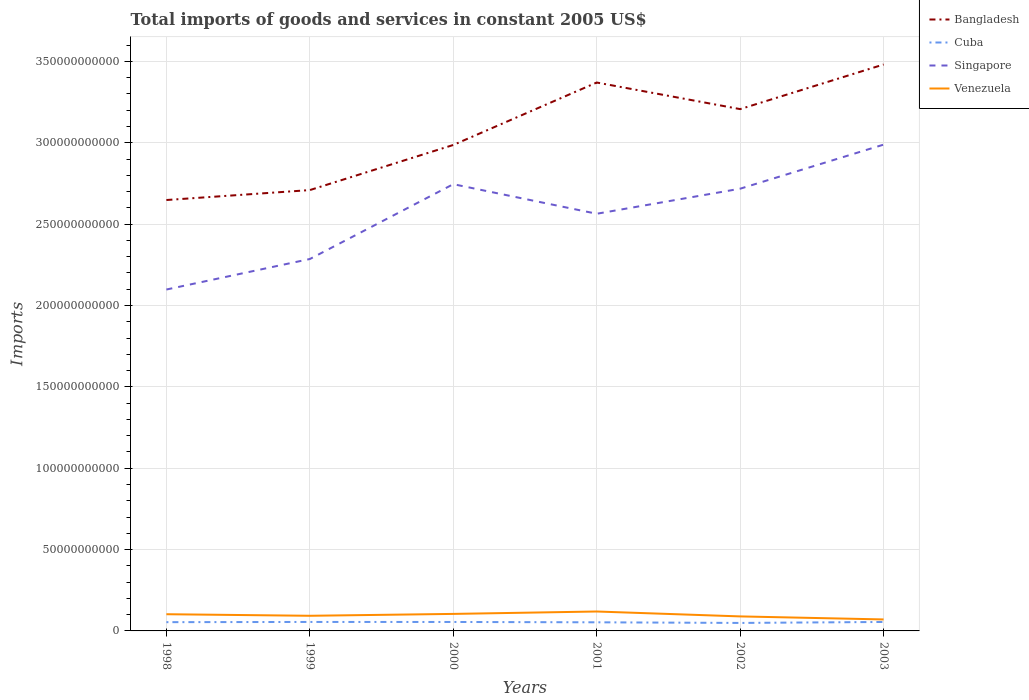How many different coloured lines are there?
Provide a succinct answer. 4. Is the number of lines equal to the number of legend labels?
Provide a succinct answer. Yes. Across all years, what is the maximum total imports of goods and services in Singapore?
Offer a terse response. 2.10e+11. What is the total total imports of goods and services in Bangladesh in the graph?
Your response must be concise. -4.98e+1. What is the difference between the highest and the second highest total imports of goods and services in Venezuela?
Provide a short and direct response. 4.87e+09. What is the difference between the highest and the lowest total imports of goods and services in Venezuela?
Make the answer very short. 3. How many years are there in the graph?
Keep it short and to the point. 6. What is the difference between two consecutive major ticks on the Y-axis?
Offer a terse response. 5.00e+1. Are the values on the major ticks of Y-axis written in scientific E-notation?
Offer a very short reply. No. Does the graph contain any zero values?
Your answer should be very brief. No. Where does the legend appear in the graph?
Provide a short and direct response. Top right. How many legend labels are there?
Your answer should be very brief. 4. How are the legend labels stacked?
Your answer should be compact. Vertical. What is the title of the graph?
Your answer should be compact. Total imports of goods and services in constant 2005 US$. What is the label or title of the Y-axis?
Your response must be concise. Imports. What is the Imports of Bangladesh in 1998?
Give a very brief answer. 2.65e+11. What is the Imports of Cuba in 1998?
Offer a terse response. 5.38e+09. What is the Imports in Singapore in 1998?
Your response must be concise. 2.10e+11. What is the Imports in Venezuela in 1998?
Offer a terse response. 1.03e+1. What is the Imports of Bangladesh in 1999?
Give a very brief answer. 2.71e+11. What is the Imports in Cuba in 1999?
Your answer should be very brief. 5.52e+09. What is the Imports of Singapore in 1999?
Your response must be concise. 2.29e+11. What is the Imports of Venezuela in 1999?
Offer a terse response. 9.30e+09. What is the Imports in Bangladesh in 2000?
Make the answer very short. 2.99e+11. What is the Imports in Cuba in 2000?
Offer a terse response. 5.50e+09. What is the Imports in Singapore in 2000?
Make the answer very short. 2.75e+11. What is the Imports of Venezuela in 2000?
Provide a succinct answer. 1.05e+1. What is the Imports in Bangladesh in 2001?
Offer a very short reply. 3.37e+11. What is the Imports of Cuba in 2001?
Keep it short and to the point. 5.30e+09. What is the Imports in Singapore in 2001?
Provide a short and direct response. 2.56e+11. What is the Imports of Venezuela in 2001?
Your answer should be very brief. 1.19e+1. What is the Imports in Bangladesh in 2002?
Your response must be concise. 3.21e+11. What is the Imports of Cuba in 2002?
Offer a terse response. 4.91e+09. What is the Imports in Singapore in 2002?
Give a very brief answer. 2.72e+11. What is the Imports in Venezuela in 2002?
Provide a short and direct response. 8.92e+09. What is the Imports of Bangladesh in 2003?
Your answer should be very brief. 3.48e+11. What is the Imports of Cuba in 2003?
Your response must be concise. 5.51e+09. What is the Imports in Singapore in 2003?
Keep it short and to the point. 2.99e+11. What is the Imports in Venezuela in 2003?
Your answer should be very brief. 7.06e+09. Across all years, what is the maximum Imports of Bangladesh?
Provide a succinct answer. 3.48e+11. Across all years, what is the maximum Imports in Cuba?
Your answer should be compact. 5.52e+09. Across all years, what is the maximum Imports in Singapore?
Provide a succinct answer. 2.99e+11. Across all years, what is the maximum Imports of Venezuela?
Offer a very short reply. 1.19e+1. Across all years, what is the minimum Imports of Bangladesh?
Your answer should be compact. 2.65e+11. Across all years, what is the minimum Imports of Cuba?
Your answer should be compact. 4.91e+09. Across all years, what is the minimum Imports of Singapore?
Provide a succinct answer. 2.10e+11. Across all years, what is the minimum Imports in Venezuela?
Give a very brief answer. 7.06e+09. What is the total Imports of Bangladesh in the graph?
Give a very brief answer. 1.84e+12. What is the total Imports of Cuba in the graph?
Provide a succinct answer. 3.21e+1. What is the total Imports of Singapore in the graph?
Your response must be concise. 1.54e+12. What is the total Imports of Venezuela in the graph?
Offer a terse response. 5.79e+1. What is the difference between the Imports of Bangladesh in 1998 and that in 1999?
Ensure brevity in your answer.  -6.11e+09. What is the difference between the Imports of Cuba in 1998 and that in 1999?
Offer a terse response. -1.31e+08. What is the difference between the Imports of Singapore in 1998 and that in 1999?
Your response must be concise. -1.87e+1. What is the difference between the Imports of Venezuela in 1998 and that in 1999?
Provide a short and direct response. 9.57e+08. What is the difference between the Imports of Bangladesh in 1998 and that in 2000?
Ensure brevity in your answer.  -3.38e+1. What is the difference between the Imports in Cuba in 1998 and that in 2000?
Keep it short and to the point. -1.19e+08. What is the difference between the Imports in Singapore in 1998 and that in 2000?
Your answer should be compact. -6.47e+1. What is the difference between the Imports in Venezuela in 1998 and that in 2000?
Offer a terse response. -1.96e+08. What is the difference between the Imports in Bangladesh in 1998 and that in 2001?
Ensure brevity in your answer.  -7.22e+1. What is the difference between the Imports of Cuba in 1998 and that in 2001?
Offer a very short reply. 8.78e+07. What is the difference between the Imports in Singapore in 1998 and that in 2001?
Ensure brevity in your answer.  -4.66e+1. What is the difference between the Imports of Venezuela in 1998 and that in 2001?
Your answer should be compact. -1.67e+09. What is the difference between the Imports in Bangladesh in 1998 and that in 2002?
Keep it short and to the point. -5.59e+1. What is the difference between the Imports of Cuba in 1998 and that in 2002?
Ensure brevity in your answer.  4.75e+08. What is the difference between the Imports in Singapore in 1998 and that in 2002?
Offer a very short reply. -6.20e+1. What is the difference between the Imports in Venezuela in 1998 and that in 2002?
Offer a very short reply. 1.34e+09. What is the difference between the Imports in Bangladesh in 1998 and that in 2003?
Offer a very short reply. -8.33e+1. What is the difference between the Imports of Cuba in 1998 and that in 2003?
Make the answer very short. -1.21e+08. What is the difference between the Imports of Singapore in 1998 and that in 2003?
Make the answer very short. -8.91e+1. What is the difference between the Imports in Venezuela in 1998 and that in 2003?
Provide a succinct answer. 3.20e+09. What is the difference between the Imports in Bangladesh in 1999 and that in 2000?
Provide a short and direct response. -2.77e+1. What is the difference between the Imports of Cuba in 1999 and that in 2000?
Offer a terse response. 1.22e+07. What is the difference between the Imports in Singapore in 1999 and that in 2000?
Provide a succinct answer. -4.60e+1. What is the difference between the Imports in Venezuela in 1999 and that in 2000?
Ensure brevity in your answer.  -1.15e+09. What is the difference between the Imports in Bangladesh in 1999 and that in 2001?
Make the answer very short. -6.61e+1. What is the difference between the Imports in Cuba in 1999 and that in 2001?
Give a very brief answer. 2.19e+08. What is the difference between the Imports in Singapore in 1999 and that in 2001?
Ensure brevity in your answer.  -2.78e+1. What is the difference between the Imports of Venezuela in 1999 and that in 2001?
Make the answer very short. -2.63e+09. What is the difference between the Imports of Bangladesh in 1999 and that in 2002?
Offer a terse response. -4.98e+1. What is the difference between the Imports in Cuba in 1999 and that in 2002?
Ensure brevity in your answer.  6.05e+08. What is the difference between the Imports of Singapore in 1999 and that in 2002?
Keep it short and to the point. -4.32e+1. What is the difference between the Imports of Venezuela in 1999 and that in 2002?
Make the answer very short. 3.80e+08. What is the difference between the Imports of Bangladesh in 1999 and that in 2003?
Provide a short and direct response. -7.72e+1. What is the difference between the Imports in Cuba in 1999 and that in 2003?
Make the answer very short. 1.01e+07. What is the difference between the Imports in Singapore in 1999 and that in 2003?
Offer a terse response. -7.03e+1. What is the difference between the Imports of Venezuela in 1999 and that in 2003?
Give a very brief answer. 2.24e+09. What is the difference between the Imports of Bangladesh in 2000 and that in 2001?
Provide a succinct answer. -3.84e+1. What is the difference between the Imports in Cuba in 2000 and that in 2001?
Your response must be concise. 2.07e+08. What is the difference between the Imports in Singapore in 2000 and that in 2001?
Offer a terse response. 1.82e+1. What is the difference between the Imports in Venezuela in 2000 and that in 2001?
Provide a short and direct response. -1.48e+09. What is the difference between the Imports of Bangladesh in 2000 and that in 2002?
Make the answer very short. -2.20e+1. What is the difference between the Imports in Cuba in 2000 and that in 2002?
Your answer should be compact. 5.93e+08. What is the difference between the Imports in Singapore in 2000 and that in 2002?
Ensure brevity in your answer.  2.78e+09. What is the difference between the Imports in Venezuela in 2000 and that in 2002?
Keep it short and to the point. 1.53e+09. What is the difference between the Imports in Bangladesh in 2000 and that in 2003?
Keep it short and to the point. -4.95e+1. What is the difference between the Imports in Cuba in 2000 and that in 2003?
Your answer should be very brief. -2.11e+06. What is the difference between the Imports in Singapore in 2000 and that in 2003?
Give a very brief answer. -2.43e+1. What is the difference between the Imports of Venezuela in 2000 and that in 2003?
Provide a succinct answer. 3.40e+09. What is the difference between the Imports in Bangladesh in 2001 and that in 2002?
Your response must be concise. 1.63e+1. What is the difference between the Imports of Cuba in 2001 and that in 2002?
Give a very brief answer. 3.87e+08. What is the difference between the Imports of Singapore in 2001 and that in 2002?
Offer a very short reply. -1.54e+1. What is the difference between the Imports in Venezuela in 2001 and that in 2002?
Offer a terse response. 3.01e+09. What is the difference between the Imports in Bangladesh in 2001 and that in 2003?
Offer a terse response. -1.11e+1. What is the difference between the Imports in Cuba in 2001 and that in 2003?
Offer a terse response. -2.09e+08. What is the difference between the Imports in Singapore in 2001 and that in 2003?
Provide a short and direct response. -4.25e+1. What is the difference between the Imports of Venezuela in 2001 and that in 2003?
Make the answer very short. 4.87e+09. What is the difference between the Imports in Bangladesh in 2002 and that in 2003?
Give a very brief answer. -2.74e+1. What is the difference between the Imports of Cuba in 2002 and that in 2003?
Keep it short and to the point. -5.95e+08. What is the difference between the Imports of Singapore in 2002 and that in 2003?
Ensure brevity in your answer.  -2.71e+1. What is the difference between the Imports in Venezuela in 2002 and that in 2003?
Your response must be concise. 1.86e+09. What is the difference between the Imports in Bangladesh in 1998 and the Imports in Cuba in 1999?
Give a very brief answer. 2.59e+11. What is the difference between the Imports of Bangladesh in 1998 and the Imports of Singapore in 1999?
Your response must be concise. 3.63e+1. What is the difference between the Imports in Bangladesh in 1998 and the Imports in Venezuela in 1999?
Provide a short and direct response. 2.56e+11. What is the difference between the Imports of Cuba in 1998 and the Imports of Singapore in 1999?
Provide a short and direct response. -2.23e+11. What is the difference between the Imports of Cuba in 1998 and the Imports of Venezuela in 1999?
Offer a very short reply. -3.92e+09. What is the difference between the Imports of Singapore in 1998 and the Imports of Venezuela in 1999?
Make the answer very short. 2.01e+11. What is the difference between the Imports of Bangladesh in 1998 and the Imports of Cuba in 2000?
Give a very brief answer. 2.59e+11. What is the difference between the Imports in Bangladesh in 1998 and the Imports in Singapore in 2000?
Provide a succinct answer. -9.73e+09. What is the difference between the Imports in Bangladesh in 1998 and the Imports in Venezuela in 2000?
Offer a terse response. 2.54e+11. What is the difference between the Imports of Cuba in 1998 and the Imports of Singapore in 2000?
Give a very brief answer. -2.69e+11. What is the difference between the Imports of Cuba in 1998 and the Imports of Venezuela in 2000?
Offer a terse response. -5.07e+09. What is the difference between the Imports of Singapore in 1998 and the Imports of Venezuela in 2000?
Provide a succinct answer. 1.99e+11. What is the difference between the Imports in Bangladesh in 1998 and the Imports in Cuba in 2001?
Your answer should be very brief. 2.60e+11. What is the difference between the Imports in Bangladesh in 1998 and the Imports in Singapore in 2001?
Offer a terse response. 8.44e+09. What is the difference between the Imports in Bangladesh in 1998 and the Imports in Venezuela in 2001?
Provide a short and direct response. 2.53e+11. What is the difference between the Imports in Cuba in 1998 and the Imports in Singapore in 2001?
Your answer should be compact. -2.51e+11. What is the difference between the Imports of Cuba in 1998 and the Imports of Venezuela in 2001?
Offer a terse response. -6.55e+09. What is the difference between the Imports of Singapore in 1998 and the Imports of Venezuela in 2001?
Provide a succinct answer. 1.98e+11. What is the difference between the Imports of Bangladesh in 1998 and the Imports of Cuba in 2002?
Keep it short and to the point. 2.60e+11. What is the difference between the Imports of Bangladesh in 1998 and the Imports of Singapore in 2002?
Give a very brief answer. -6.95e+09. What is the difference between the Imports in Bangladesh in 1998 and the Imports in Venezuela in 2002?
Give a very brief answer. 2.56e+11. What is the difference between the Imports in Cuba in 1998 and the Imports in Singapore in 2002?
Keep it short and to the point. -2.66e+11. What is the difference between the Imports in Cuba in 1998 and the Imports in Venezuela in 2002?
Provide a short and direct response. -3.54e+09. What is the difference between the Imports of Singapore in 1998 and the Imports of Venezuela in 2002?
Your response must be concise. 2.01e+11. What is the difference between the Imports in Bangladesh in 1998 and the Imports in Cuba in 2003?
Give a very brief answer. 2.59e+11. What is the difference between the Imports of Bangladesh in 1998 and the Imports of Singapore in 2003?
Offer a terse response. -3.40e+1. What is the difference between the Imports in Bangladesh in 1998 and the Imports in Venezuela in 2003?
Provide a succinct answer. 2.58e+11. What is the difference between the Imports in Cuba in 1998 and the Imports in Singapore in 2003?
Ensure brevity in your answer.  -2.93e+11. What is the difference between the Imports in Cuba in 1998 and the Imports in Venezuela in 2003?
Ensure brevity in your answer.  -1.68e+09. What is the difference between the Imports in Singapore in 1998 and the Imports in Venezuela in 2003?
Keep it short and to the point. 2.03e+11. What is the difference between the Imports of Bangladesh in 1999 and the Imports of Cuba in 2000?
Offer a very short reply. 2.65e+11. What is the difference between the Imports in Bangladesh in 1999 and the Imports in Singapore in 2000?
Provide a short and direct response. -3.63e+09. What is the difference between the Imports of Bangladesh in 1999 and the Imports of Venezuela in 2000?
Provide a short and direct response. 2.60e+11. What is the difference between the Imports of Cuba in 1999 and the Imports of Singapore in 2000?
Your answer should be compact. -2.69e+11. What is the difference between the Imports of Cuba in 1999 and the Imports of Venezuela in 2000?
Offer a very short reply. -4.94e+09. What is the difference between the Imports in Singapore in 1999 and the Imports in Venezuela in 2000?
Your answer should be very brief. 2.18e+11. What is the difference between the Imports of Bangladesh in 1999 and the Imports of Cuba in 2001?
Your answer should be compact. 2.66e+11. What is the difference between the Imports in Bangladesh in 1999 and the Imports in Singapore in 2001?
Your response must be concise. 1.45e+1. What is the difference between the Imports of Bangladesh in 1999 and the Imports of Venezuela in 2001?
Your answer should be very brief. 2.59e+11. What is the difference between the Imports of Cuba in 1999 and the Imports of Singapore in 2001?
Give a very brief answer. -2.51e+11. What is the difference between the Imports in Cuba in 1999 and the Imports in Venezuela in 2001?
Keep it short and to the point. -6.42e+09. What is the difference between the Imports of Singapore in 1999 and the Imports of Venezuela in 2001?
Your answer should be compact. 2.17e+11. What is the difference between the Imports in Bangladesh in 1999 and the Imports in Cuba in 2002?
Offer a very short reply. 2.66e+11. What is the difference between the Imports of Bangladesh in 1999 and the Imports of Singapore in 2002?
Your response must be concise. -8.46e+08. What is the difference between the Imports in Bangladesh in 1999 and the Imports in Venezuela in 2002?
Offer a terse response. 2.62e+11. What is the difference between the Imports of Cuba in 1999 and the Imports of Singapore in 2002?
Provide a short and direct response. -2.66e+11. What is the difference between the Imports of Cuba in 1999 and the Imports of Venezuela in 2002?
Provide a succinct answer. -3.41e+09. What is the difference between the Imports in Singapore in 1999 and the Imports in Venezuela in 2002?
Make the answer very short. 2.20e+11. What is the difference between the Imports in Bangladesh in 1999 and the Imports in Cuba in 2003?
Provide a short and direct response. 2.65e+11. What is the difference between the Imports in Bangladesh in 1999 and the Imports in Singapore in 2003?
Your answer should be compact. -2.79e+1. What is the difference between the Imports of Bangladesh in 1999 and the Imports of Venezuela in 2003?
Keep it short and to the point. 2.64e+11. What is the difference between the Imports of Cuba in 1999 and the Imports of Singapore in 2003?
Your answer should be very brief. -2.93e+11. What is the difference between the Imports of Cuba in 1999 and the Imports of Venezuela in 2003?
Ensure brevity in your answer.  -1.54e+09. What is the difference between the Imports in Singapore in 1999 and the Imports in Venezuela in 2003?
Make the answer very short. 2.22e+11. What is the difference between the Imports in Bangladesh in 2000 and the Imports in Cuba in 2001?
Your answer should be compact. 2.93e+11. What is the difference between the Imports in Bangladesh in 2000 and the Imports in Singapore in 2001?
Provide a short and direct response. 4.23e+1. What is the difference between the Imports in Bangladesh in 2000 and the Imports in Venezuela in 2001?
Keep it short and to the point. 2.87e+11. What is the difference between the Imports in Cuba in 2000 and the Imports in Singapore in 2001?
Ensure brevity in your answer.  -2.51e+11. What is the difference between the Imports of Cuba in 2000 and the Imports of Venezuela in 2001?
Provide a succinct answer. -6.43e+09. What is the difference between the Imports in Singapore in 2000 and the Imports in Venezuela in 2001?
Keep it short and to the point. 2.63e+11. What is the difference between the Imports of Bangladesh in 2000 and the Imports of Cuba in 2002?
Ensure brevity in your answer.  2.94e+11. What is the difference between the Imports of Bangladesh in 2000 and the Imports of Singapore in 2002?
Give a very brief answer. 2.69e+1. What is the difference between the Imports of Bangladesh in 2000 and the Imports of Venezuela in 2002?
Your response must be concise. 2.90e+11. What is the difference between the Imports of Cuba in 2000 and the Imports of Singapore in 2002?
Your answer should be very brief. -2.66e+11. What is the difference between the Imports of Cuba in 2000 and the Imports of Venezuela in 2002?
Give a very brief answer. -3.42e+09. What is the difference between the Imports in Singapore in 2000 and the Imports in Venezuela in 2002?
Offer a very short reply. 2.66e+11. What is the difference between the Imports of Bangladesh in 2000 and the Imports of Cuba in 2003?
Make the answer very short. 2.93e+11. What is the difference between the Imports of Bangladesh in 2000 and the Imports of Singapore in 2003?
Provide a short and direct response. -2.12e+08. What is the difference between the Imports in Bangladesh in 2000 and the Imports in Venezuela in 2003?
Your answer should be very brief. 2.92e+11. What is the difference between the Imports in Cuba in 2000 and the Imports in Singapore in 2003?
Make the answer very short. -2.93e+11. What is the difference between the Imports in Cuba in 2000 and the Imports in Venezuela in 2003?
Keep it short and to the point. -1.56e+09. What is the difference between the Imports in Singapore in 2000 and the Imports in Venezuela in 2003?
Provide a succinct answer. 2.68e+11. What is the difference between the Imports of Bangladesh in 2001 and the Imports of Cuba in 2002?
Keep it short and to the point. 3.32e+11. What is the difference between the Imports in Bangladesh in 2001 and the Imports in Singapore in 2002?
Give a very brief answer. 6.53e+1. What is the difference between the Imports of Bangladesh in 2001 and the Imports of Venezuela in 2002?
Ensure brevity in your answer.  3.28e+11. What is the difference between the Imports of Cuba in 2001 and the Imports of Singapore in 2002?
Make the answer very short. -2.66e+11. What is the difference between the Imports in Cuba in 2001 and the Imports in Venezuela in 2002?
Keep it short and to the point. -3.63e+09. What is the difference between the Imports of Singapore in 2001 and the Imports of Venezuela in 2002?
Give a very brief answer. 2.47e+11. What is the difference between the Imports in Bangladesh in 2001 and the Imports in Cuba in 2003?
Give a very brief answer. 3.32e+11. What is the difference between the Imports of Bangladesh in 2001 and the Imports of Singapore in 2003?
Your answer should be compact. 3.82e+1. What is the difference between the Imports in Bangladesh in 2001 and the Imports in Venezuela in 2003?
Your response must be concise. 3.30e+11. What is the difference between the Imports of Cuba in 2001 and the Imports of Singapore in 2003?
Ensure brevity in your answer.  -2.94e+11. What is the difference between the Imports of Cuba in 2001 and the Imports of Venezuela in 2003?
Keep it short and to the point. -1.76e+09. What is the difference between the Imports in Singapore in 2001 and the Imports in Venezuela in 2003?
Give a very brief answer. 2.49e+11. What is the difference between the Imports in Bangladesh in 2002 and the Imports in Cuba in 2003?
Give a very brief answer. 3.15e+11. What is the difference between the Imports in Bangladesh in 2002 and the Imports in Singapore in 2003?
Give a very brief answer. 2.18e+1. What is the difference between the Imports in Bangladesh in 2002 and the Imports in Venezuela in 2003?
Your answer should be compact. 3.14e+11. What is the difference between the Imports in Cuba in 2002 and the Imports in Singapore in 2003?
Provide a short and direct response. -2.94e+11. What is the difference between the Imports in Cuba in 2002 and the Imports in Venezuela in 2003?
Provide a short and direct response. -2.15e+09. What is the difference between the Imports of Singapore in 2002 and the Imports of Venezuela in 2003?
Your answer should be very brief. 2.65e+11. What is the average Imports of Bangladesh per year?
Give a very brief answer. 3.07e+11. What is the average Imports of Cuba per year?
Provide a succinct answer. 5.35e+09. What is the average Imports in Singapore per year?
Give a very brief answer. 2.57e+11. What is the average Imports in Venezuela per year?
Your answer should be compact. 9.66e+09. In the year 1998, what is the difference between the Imports of Bangladesh and Imports of Cuba?
Keep it short and to the point. 2.59e+11. In the year 1998, what is the difference between the Imports of Bangladesh and Imports of Singapore?
Your answer should be very brief. 5.50e+1. In the year 1998, what is the difference between the Imports in Bangladesh and Imports in Venezuela?
Ensure brevity in your answer.  2.55e+11. In the year 1998, what is the difference between the Imports in Cuba and Imports in Singapore?
Your response must be concise. -2.04e+11. In the year 1998, what is the difference between the Imports of Cuba and Imports of Venezuela?
Provide a short and direct response. -4.88e+09. In the year 1998, what is the difference between the Imports in Singapore and Imports in Venezuela?
Your answer should be very brief. 2.00e+11. In the year 1999, what is the difference between the Imports in Bangladesh and Imports in Cuba?
Your answer should be compact. 2.65e+11. In the year 1999, what is the difference between the Imports in Bangladesh and Imports in Singapore?
Provide a succinct answer. 4.24e+1. In the year 1999, what is the difference between the Imports of Bangladesh and Imports of Venezuela?
Make the answer very short. 2.62e+11. In the year 1999, what is the difference between the Imports of Cuba and Imports of Singapore?
Your answer should be compact. -2.23e+11. In the year 1999, what is the difference between the Imports of Cuba and Imports of Venezuela?
Offer a very short reply. -3.79e+09. In the year 1999, what is the difference between the Imports in Singapore and Imports in Venezuela?
Give a very brief answer. 2.19e+11. In the year 2000, what is the difference between the Imports in Bangladesh and Imports in Cuba?
Ensure brevity in your answer.  2.93e+11. In the year 2000, what is the difference between the Imports in Bangladesh and Imports in Singapore?
Provide a short and direct response. 2.41e+1. In the year 2000, what is the difference between the Imports in Bangladesh and Imports in Venezuela?
Provide a succinct answer. 2.88e+11. In the year 2000, what is the difference between the Imports of Cuba and Imports of Singapore?
Your answer should be very brief. -2.69e+11. In the year 2000, what is the difference between the Imports in Cuba and Imports in Venezuela?
Offer a very short reply. -4.95e+09. In the year 2000, what is the difference between the Imports in Singapore and Imports in Venezuela?
Ensure brevity in your answer.  2.64e+11. In the year 2001, what is the difference between the Imports in Bangladesh and Imports in Cuba?
Provide a succinct answer. 3.32e+11. In the year 2001, what is the difference between the Imports of Bangladesh and Imports of Singapore?
Provide a short and direct response. 8.07e+1. In the year 2001, what is the difference between the Imports of Bangladesh and Imports of Venezuela?
Give a very brief answer. 3.25e+11. In the year 2001, what is the difference between the Imports of Cuba and Imports of Singapore?
Keep it short and to the point. -2.51e+11. In the year 2001, what is the difference between the Imports in Cuba and Imports in Venezuela?
Provide a short and direct response. -6.64e+09. In the year 2001, what is the difference between the Imports in Singapore and Imports in Venezuela?
Keep it short and to the point. 2.44e+11. In the year 2002, what is the difference between the Imports in Bangladesh and Imports in Cuba?
Keep it short and to the point. 3.16e+11. In the year 2002, what is the difference between the Imports in Bangladesh and Imports in Singapore?
Provide a short and direct response. 4.89e+1. In the year 2002, what is the difference between the Imports of Bangladesh and Imports of Venezuela?
Offer a very short reply. 3.12e+11. In the year 2002, what is the difference between the Imports of Cuba and Imports of Singapore?
Give a very brief answer. -2.67e+11. In the year 2002, what is the difference between the Imports in Cuba and Imports in Venezuela?
Give a very brief answer. -4.01e+09. In the year 2002, what is the difference between the Imports in Singapore and Imports in Venezuela?
Your answer should be very brief. 2.63e+11. In the year 2003, what is the difference between the Imports of Bangladesh and Imports of Cuba?
Ensure brevity in your answer.  3.43e+11. In the year 2003, what is the difference between the Imports in Bangladesh and Imports in Singapore?
Provide a succinct answer. 4.92e+1. In the year 2003, what is the difference between the Imports of Bangladesh and Imports of Venezuela?
Keep it short and to the point. 3.41e+11. In the year 2003, what is the difference between the Imports in Cuba and Imports in Singapore?
Your response must be concise. -2.93e+11. In the year 2003, what is the difference between the Imports of Cuba and Imports of Venezuela?
Offer a terse response. -1.55e+09. In the year 2003, what is the difference between the Imports of Singapore and Imports of Venezuela?
Offer a very short reply. 2.92e+11. What is the ratio of the Imports of Bangladesh in 1998 to that in 1999?
Ensure brevity in your answer.  0.98. What is the ratio of the Imports in Cuba in 1998 to that in 1999?
Give a very brief answer. 0.98. What is the ratio of the Imports of Singapore in 1998 to that in 1999?
Your answer should be compact. 0.92. What is the ratio of the Imports in Venezuela in 1998 to that in 1999?
Your answer should be very brief. 1.1. What is the ratio of the Imports in Bangladesh in 1998 to that in 2000?
Ensure brevity in your answer.  0.89. What is the ratio of the Imports in Cuba in 1998 to that in 2000?
Give a very brief answer. 0.98. What is the ratio of the Imports in Singapore in 1998 to that in 2000?
Your answer should be very brief. 0.76. What is the ratio of the Imports in Venezuela in 1998 to that in 2000?
Give a very brief answer. 0.98. What is the ratio of the Imports in Bangladesh in 1998 to that in 2001?
Provide a short and direct response. 0.79. What is the ratio of the Imports of Cuba in 1998 to that in 2001?
Provide a succinct answer. 1.02. What is the ratio of the Imports of Singapore in 1998 to that in 2001?
Provide a short and direct response. 0.82. What is the ratio of the Imports of Venezuela in 1998 to that in 2001?
Provide a succinct answer. 0.86. What is the ratio of the Imports of Bangladesh in 1998 to that in 2002?
Offer a terse response. 0.83. What is the ratio of the Imports of Cuba in 1998 to that in 2002?
Make the answer very short. 1.1. What is the ratio of the Imports of Singapore in 1998 to that in 2002?
Provide a short and direct response. 0.77. What is the ratio of the Imports of Venezuela in 1998 to that in 2002?
Your answer should be compact. 1.15. What is the ratio of the Imports of Bangladesh in 1998 to that in 2003?
Provide a succinct answer. 0.76. What is the ratio of the Imports in Cuba in 1998 to that in 2003?
Ensure brevity in your answer.  0.98. What is the ratio of the Imports of Singapore in 1998 to that in 2003?
Make the answer very short. 0.7. What is the ratio of the Imports of Venezuela in 1998 to that in 2003?
Your answer should be very brief. 1.45. What is the ratio of the Imports of Bangladesh in 1999 to that in 2000?
Keep it short and to the point. 0.91. What is the ratio of the Imports in Cuba in 1999 to that in 2000?
Your response must be concise. 1. What is the ratio of the Imports in Singapore in 1999 to that in 2000?
Your answer should be very brief. 0.83. What is the ratio of the Imports of Venezuela in 1999 to that in 2000?
Your answer should be compact. 0.89. What is the ratio of the Imports of Bangladesh in 1999 to that in 2001?
Keep it short and to the point. 0.8. What is the ratio of the Imports in Cuba in 1999 to that in 2001?
Keep it short and to the point. 1.04. What is the ratio of the Imports in Singapore in 1999 to that in 2001?
Your answer should be very brief. 0.89. What is the ratio of the Imports in Venezuela in 1999 to that in 2001?
Your answer should be very brief. 0.78. What is the ratio of the Imports of Bangladesh in 1999 to that in 2002?
Keep it short and to the point. 0.84. What is the ratio of the Imports of Cuba in 1999 to that in 2002?
Offer a terse response. 1.12. What is the ratio of the Imports in Singapore in 1999 to that in 2002?
Make the answer very short. 0.84. What is the ratio of the Imports in Venezuela in 1999 to that in 2002?
Make the answer very short. 1.04. What is the ratio of the Imports in Bangladesh in 1999 to that in 2003?
Offer a very short reply. 0.78. What is the ratio of the Imports of Singapore in 1999 to that in 2003?
Your answer should be very brief. 0.76. What is the ratio of the Imports of Venezuela in 1999 to that in 2003?
Offer a terse response. 1.32. What is the ratio of the Imports of Bangladesh in 2000 to that in 2001?
Provide a succinct answer. 0.89. What is the ratio of the Imports of Cuba in 2000 to that in 2001?
Ensure brevity in your answer.  1.04. What is the ratio of the Imports of Singapore in 2000 to that in 2001?
Your answer should be compact. 1.07. What is the ratio of the Imports of Venezuela in 2000 to that in 2001?
Provide a succinct answer. 0.88. What is the ratio of the Imports of Bangladesh in 2000 to that in 2002?
Provide a succinct answer. 0.93. What is the ratio of the Imports of Cuba in 2000 to that in 2002?
Provide a short and direct response. 1.12. What is the ratio of the Imports of Singapore in 2000 to that in 2002?
Your answer should be compact. 1.01. What is the ratio of the Imports in Venezuela in 2000 to that in 2002?
Offer a very short reply. 1.17. What is the ratio of the Imports of Bangladesh in 2000 to that in 2003?
Keep it short and to the point. 0.86. What is the ratio of the Imports of Singapore in 2000 to that in 2003?
Provide a short and direct response. 0.92. What is the ratio of the Imports of Venezuela in 2000 to that in 2003?
Your answer should be compact. 1.48. What is the ratio of the Imports in Bangladesh in 2001 to that in 2002?
Keep it short and to the point. 1.05. What is the ratio of the Imports of Cuba in 2001 to that in 2002?
Offer a terse response. 1.08. What is the ratio of the Imports of Singapore in 2001 to that in 2002?
Keep it short and to the point. 0.94. What is the ratio of the Imports in Venezuela in 2001 to that in 2002?
Give a very brief answer. 1.34. What is the ratio of the Imports in Bangladesh in 2001 to that in 2003?
Make the answer very short. 0.97. What is the ratio of the Imports of Cuba in 2001 to that in 2003?
Ensure brevity in your answer.  0.96. What is the ratio of the Imports of Singapore in 2001 to that in 2003?
Ensure brevity in your answer.  0.86. What is the ratio of the Imports in Venezuela in 2001 to that in 2003?
Provide a succinct answer. 1.69. What is the ratio of the Imports of Bangladesh in 2002 to that in 2003?
Ensure brevity in your answer.  0.92. What is the ratio of the Imports in Cuba in 2002 to that in 2003?
Offer a very short reply. 0.89. What is the ratio of the Imports of Singapore in 2002 to that in 2003?
Ensure brevity in your answer.  0.91. What is the ratio of the Imports in Venezuela in 2002 to that in 2003?
Your answer should be compact. 1.26. What is the difference between the highest and the second highest Imports of Bangladesh?
Provide a succinct answer. 1.11e+1. What is the difference between the highest and the second highest Imports in Cuba?
Ensure brevity in your answer.  1.01e+07. What is the difference between the highest and the second highest Imports of Singapore?
Give a very brief answer. 2.43e+1. What is the difference between the highest and the second highest Imports in Venezuela?
Offer a very short reply. 1.48e+09. What is the difference between the highest and the lowest Imports of Bangladesh?
Your answer should be very brief. 8.33e+1. What is the difference between the highest and the lowest Imports in Cuba?
Offer a terse response. 6.05e+08. What is the difference between the highest and the lowest Imports in Singapore?
Offer a very short reply. 8.91e+1. What is the difference between the highest and the lowest Imports of Venezuela?
Keep it short and to the point. 4.87e+09. 